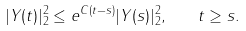<formula> <loc_0><loc_0><loc_500><loc_500>| Y ( t ) | ^ { 2 } _ { 2 } \leq e ^ { C ( t - s ) } | Y ( s ) | ^ { 2 } _ { 2 } , \quad t \geq s .</formula> 